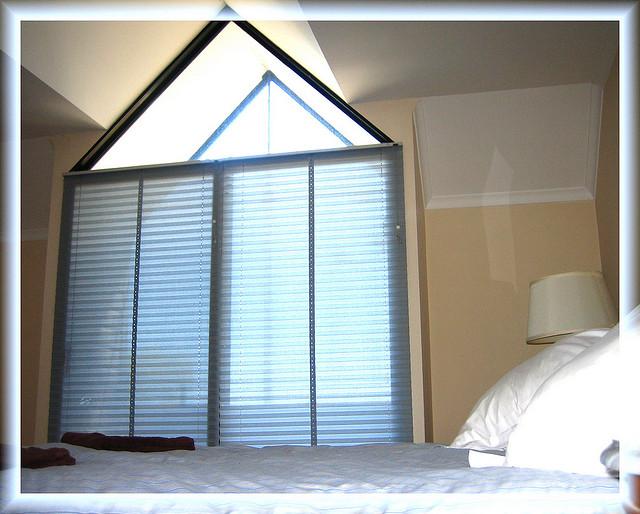Is the bed made?
Quick response, please. Yes. Is the lamp on or off?
Write a very short answer. Off. Why are the blinds closed?
Write a very short answer. Privacy. 